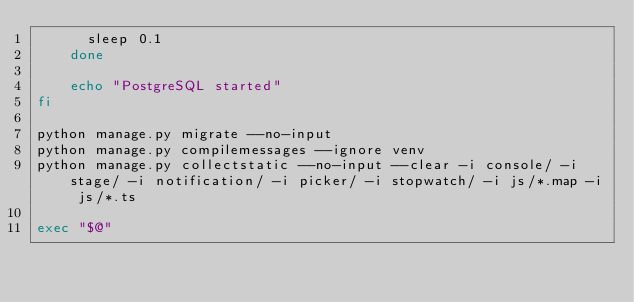<code> <loc_0><loc_0><loc_500><loc_500><_Bash_>      sleep 0.1
    done

    echo "PostgreSQL started"
fi

python manage.py migrate --no-input
python manage.py compilemessages --ignore venv
python manage.py collectstatic --no-input --clear -i console/ -i stage/ -i notification/ -i picker/ -i stopwatch/ -i js/*.map -i js/*.ts

exec "$@"</code> 